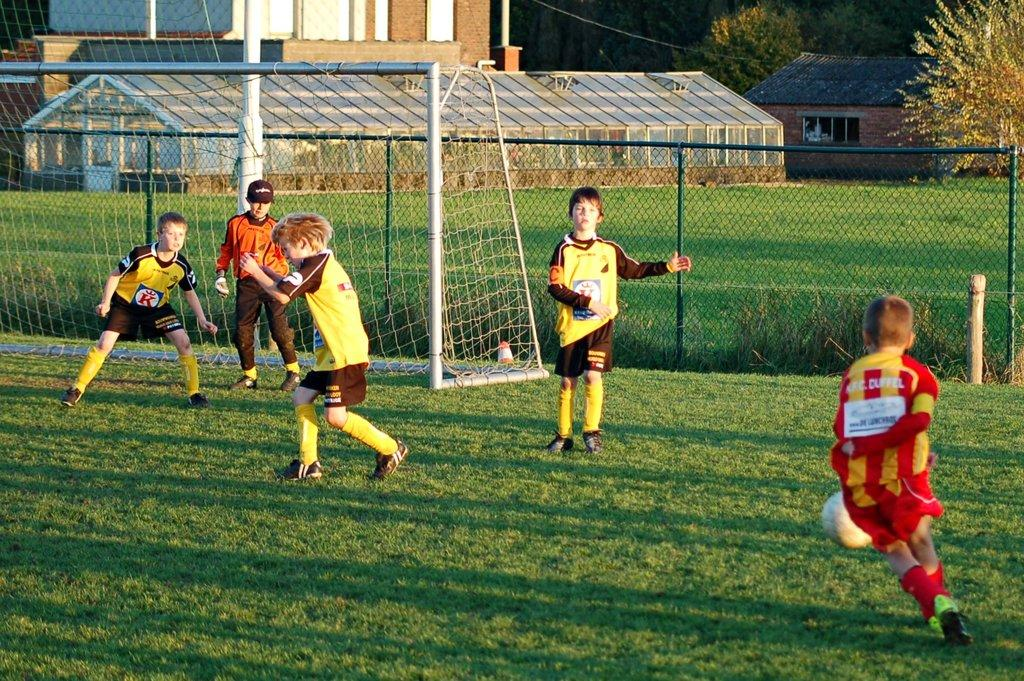Provide a one-sentence caption for the provided image. The yellow team with a K on their jerseys is going against a red team in a soccer game. 